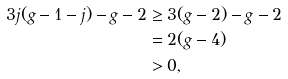Convert formula to latex. <formula><loc_0><loc_0><loc_500><loc_500>3 j ( g - 1 - j ) - g - 2 & \geq 3 ( g - 2 ) - g - 2 \\ & = 2 ( g - 4 ) \\ & > 0 ,</formula> 